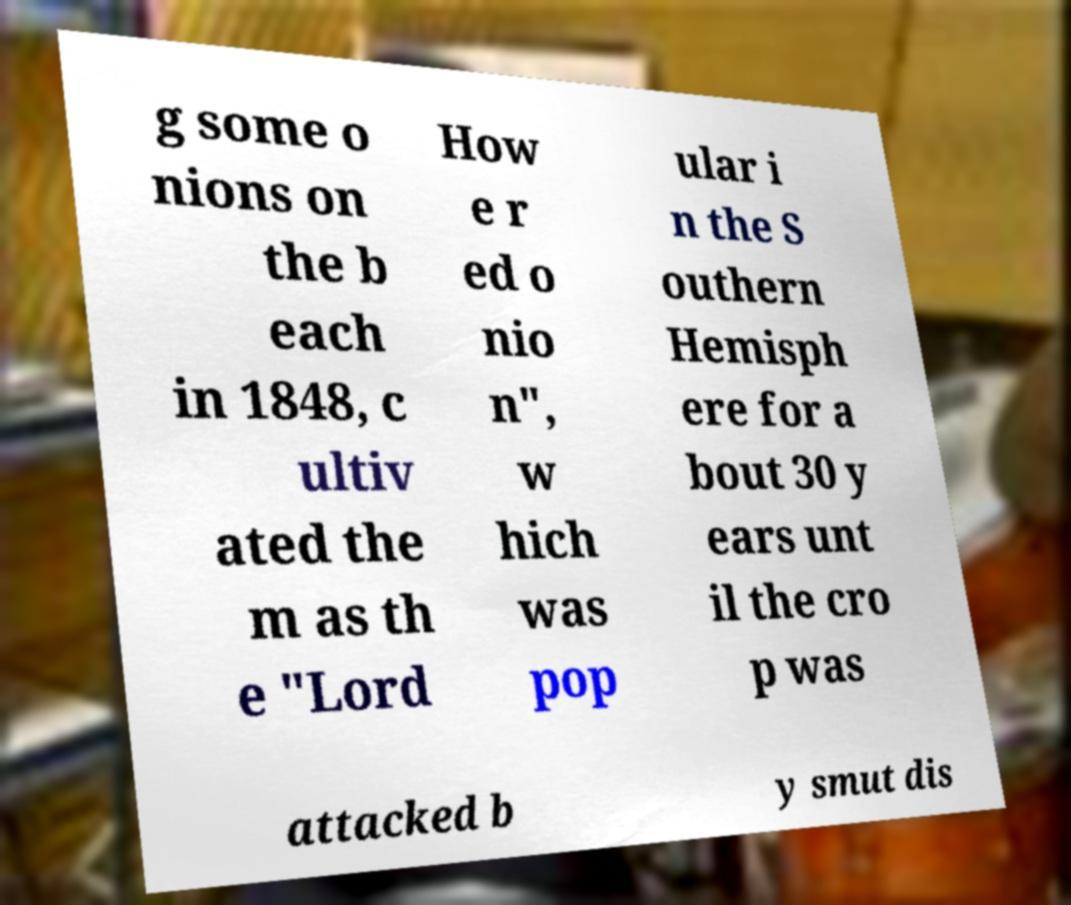For documentation purposes, I need the text within this image transcribed. Could you provide that? g some o nions on the b each in 1848, c ultiv ated the m as th e "Lord How e r ed o nio n", w hich was pop ular i n the S outhern Hemisph ere for a bout 30 y ears unt il the cro p was attacked b y smut dis 